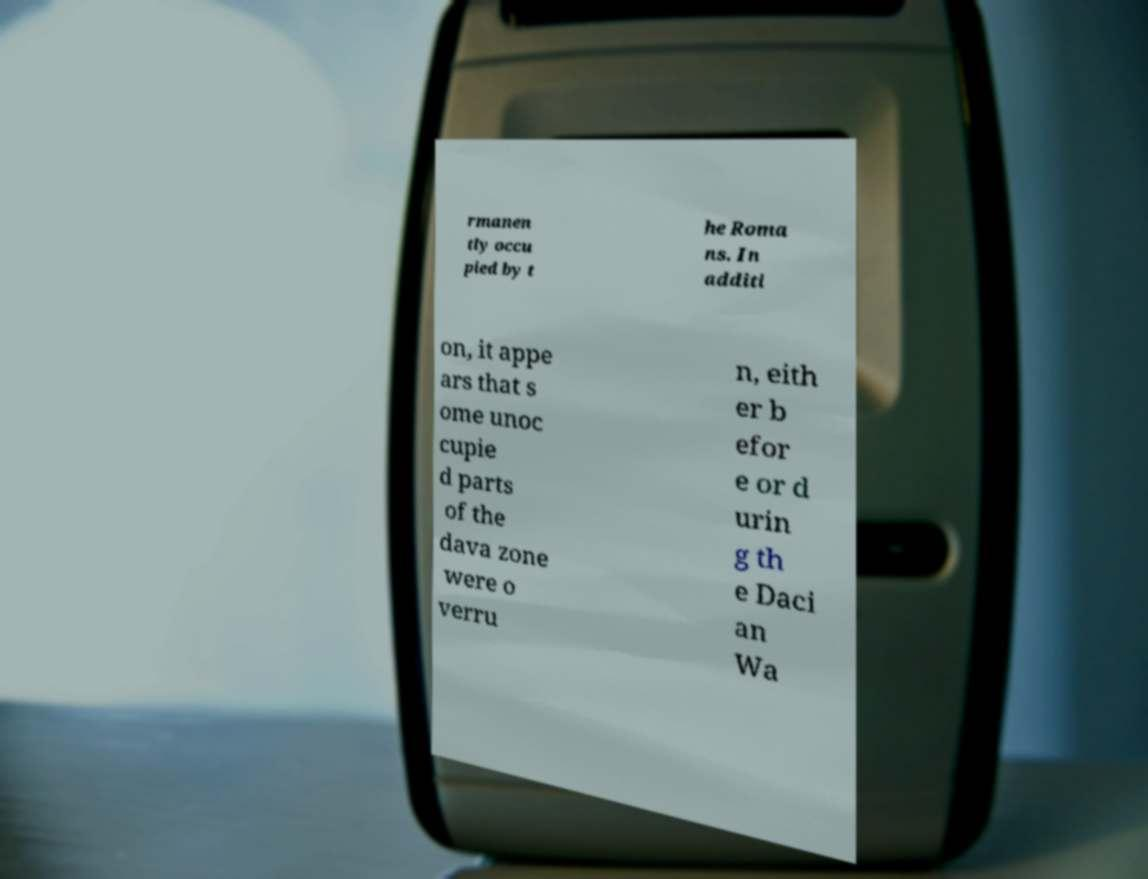Please read and relay the text visible in this image. What does it say? rmanen tly occu pied by t he Roma ns. In additi on, it appe ars that s ome unoc cupie d parts of the dava zone were o verru n, eith er b efor e or d urin g th e Daci an Wa 